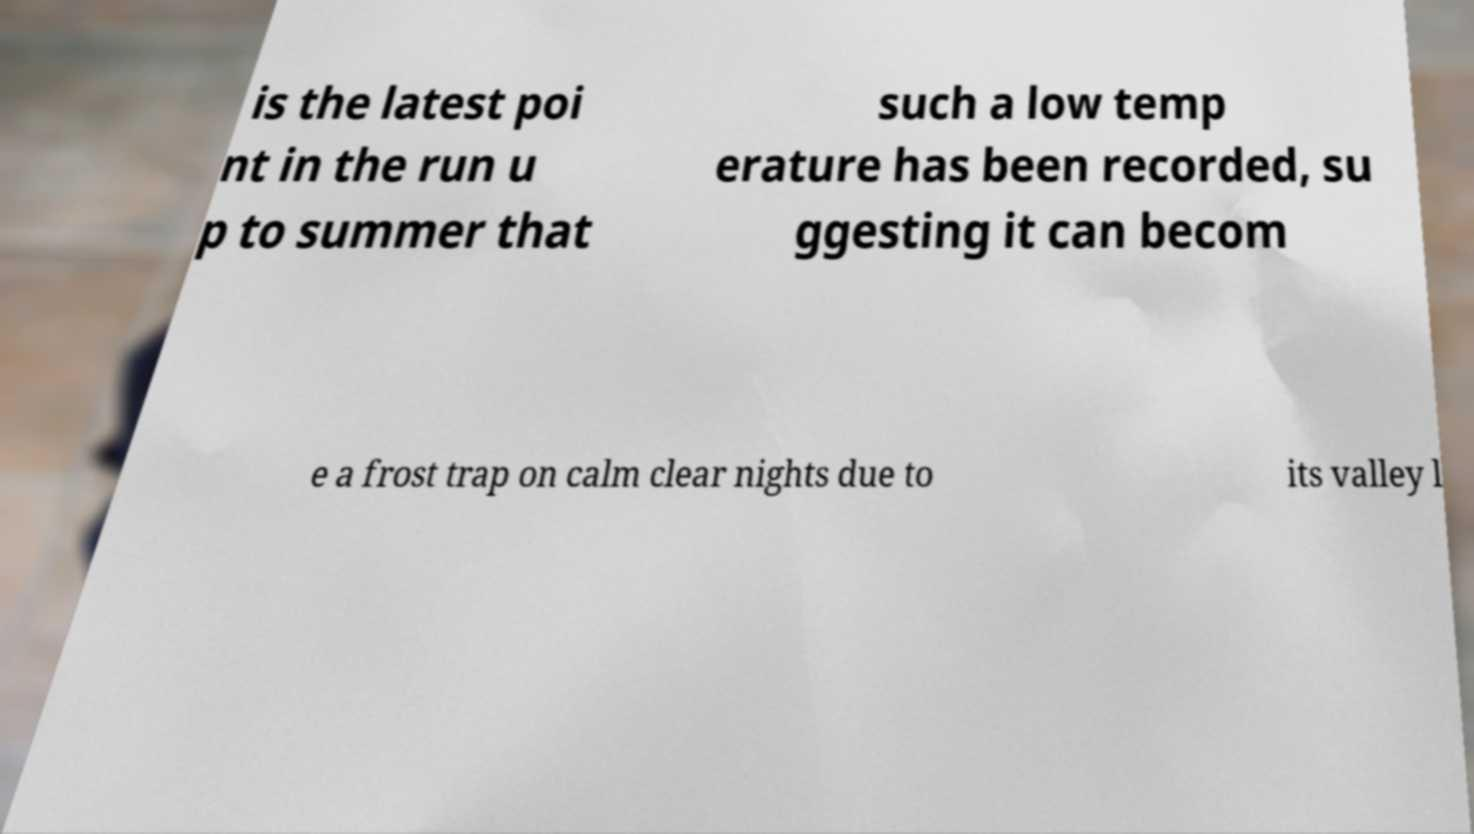I need the written content from this picture converted into text. Can you do that? is the latest poi nt in the run u p to summer that such a low temp erature has been recorded, su ggesting it can becom e a frost trap on calm clear nights due to its valley l 